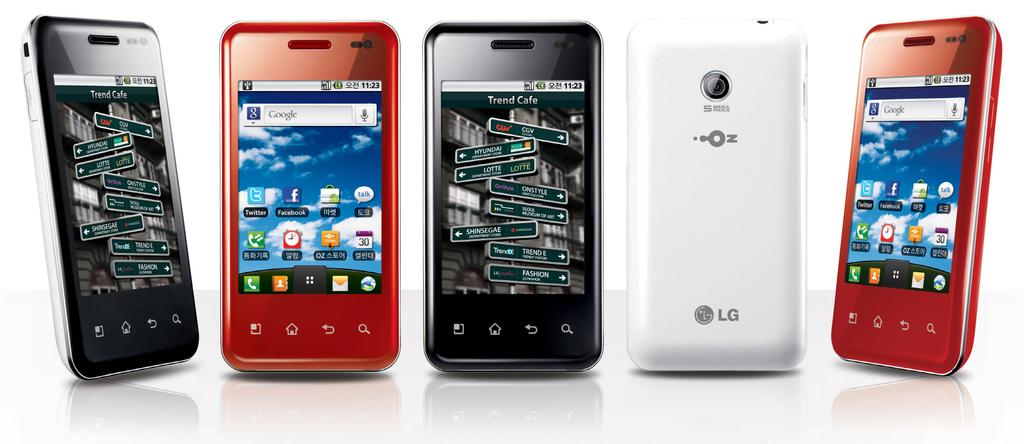<image>
Provide a brief description of the given image. Five LG smartphones are lined up, all but one facing forward. 